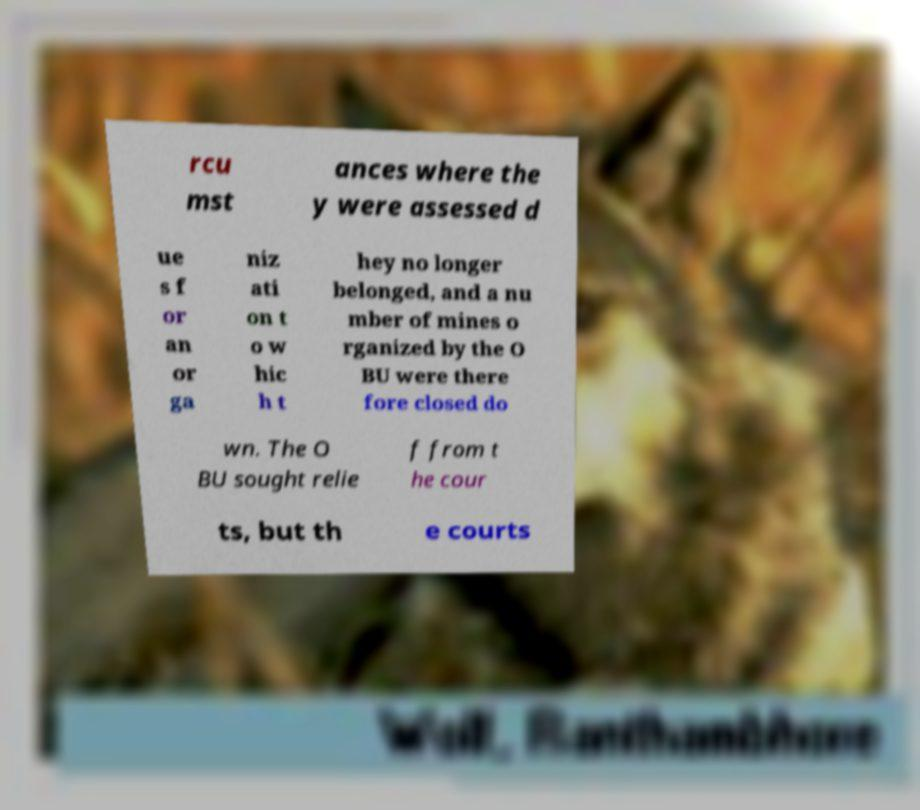For documentation purposes, I need the text within this image transcribed. Could you provide that? rcu mst ances where the y were assessed d ue s f or an or ga niz ati on t o w hic h t hey no longer belonged, and a nu mber of mines o rganized by the O BU were there fore closed do wn. The O BU sought relie f from t he cour ts, but th e courts 